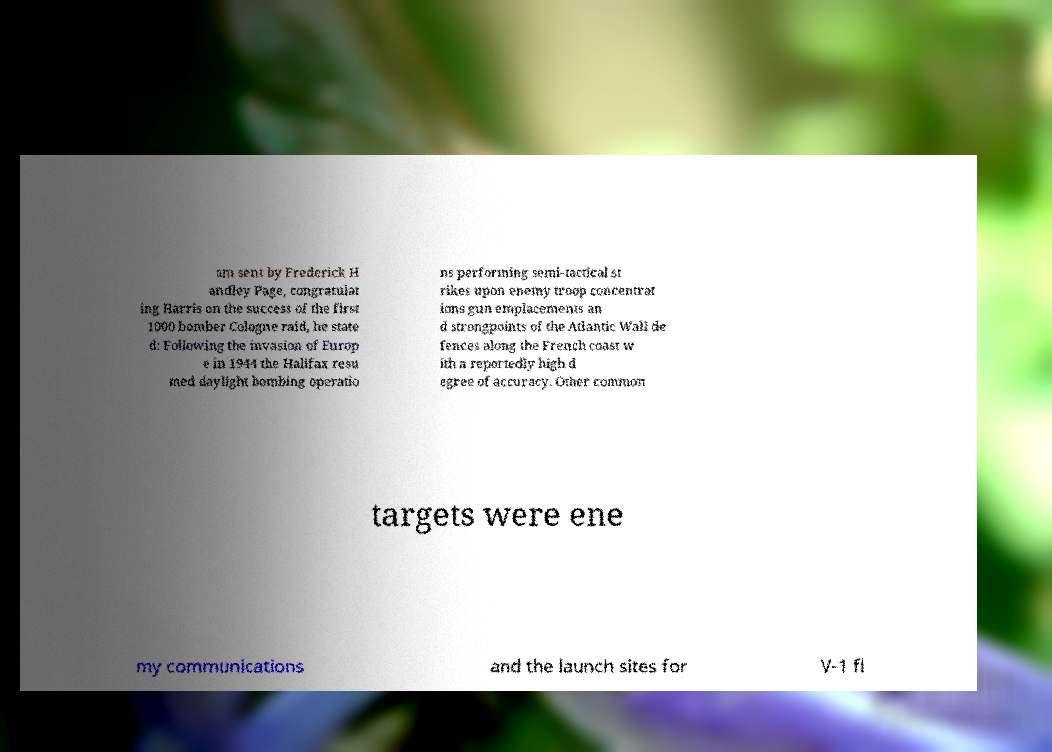For documentation purposes, I need the text within this image transcribed. Could you provide that? am sent by Frederick H andley Page, congratulat ing Harris on the success of the first 1000 bomber Cologne raid, he state d: Following the invasion of Europ e in 1944 the Halifax resu med daylight bombing operatio ns performing semi-tactical st rikes upon enemy troop concentrat ions gun emplacements an d strongpoints of the Atlantic Wall de fences along the French coast w ith a reportedly high d egree of accuracy. Other common targets were ene my communications and the launch sites for V-1 fl 